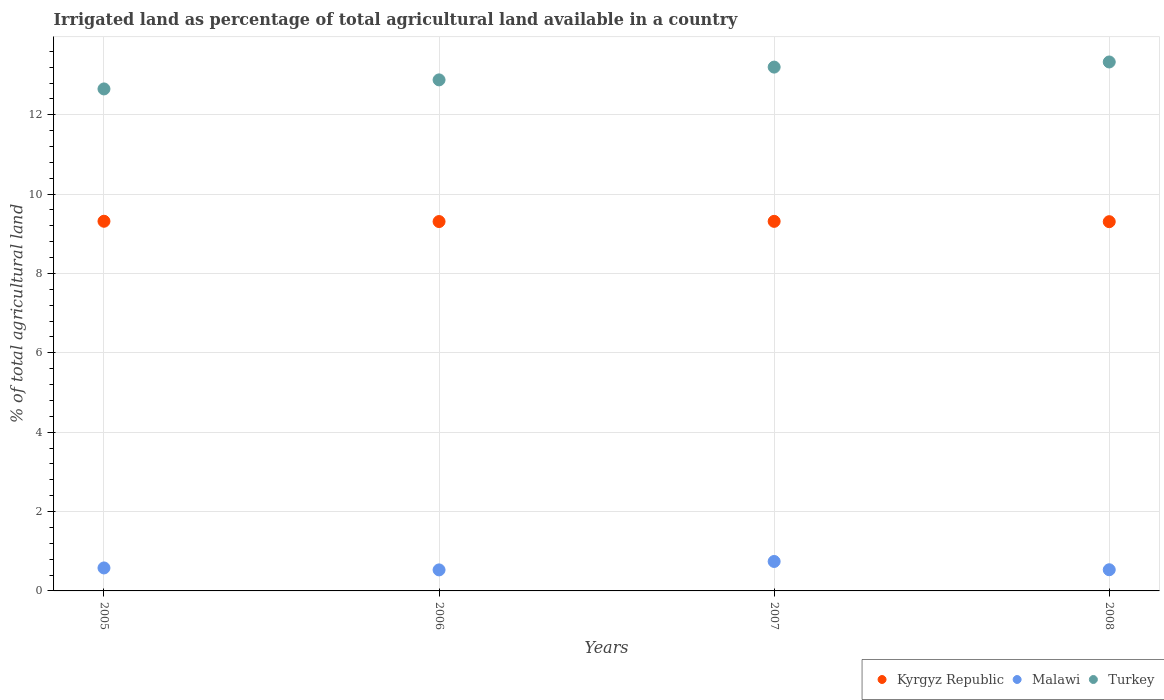How many different coloured dotlines are there?
Make the answer very short. 3. Is the number of dotlines equal to the number of legend labels?
Your answer should be compact. Yes. What is the percentage of irrigated land in Kyrgyz Republic in 2007?
Your response must be concise. 9.31. Across all years, what is the maximum percentage of irrigated land in Turkey?
Give a very brief answer. 13.33. Across all years, what is the minimum percentage of irrigated land in Kyrgyz Republic?
Keep it short and to the point. 9.31. In which year was the percentage of irrigated land in Kyrgyz Republic maximum?
Your answer should be very brief. 2005. In which year was the percentage of irrigated land in Kyrgyz Republic minimum?
Offer a very short reply. 2008. What is the total percentage of irrigated land in Turkey in the graph?
Ensure brevity in your answer.  52.06. What is the difference between the percentage of irrigated land in Turkey in 2005 and that in 2006?
Your answer should be compact. -0.23. What is the difference between the percentage of irrigated land in Malawi in 2006 and the percentage of irrigated land in Kyrgyz Republic in 2008?
Offer a very short reply. -8.78. What is the average percentage of irrigated land in Malawi per year?
Provide a short and direct response. 0.6. In the year 2007, what is the difference between the percentage of irrigated land in Kyrgyz Republic and percentage of irrigated land in Malawi?
Keep it short and to the point. 8.57. What is the ratio of the percentage of irrigated land in Malawi in 2007 to that in 2008?
Give a very brief answer. 1.39. Is the percentage of irrigated land in Malawi in 2005 less than that in 2006?
Your answer should be compact. No. What is the difference between the highest and the second highest percentage of irrigated land in Malawi?
Ensure brevity in your answer.  0.16. What is the difference between the highest and the lowest percentage of irrigated land in Kyrgyz Republic?
Offer a terse response. 0.01. In how many years, is the percentage of irrigated land in Kyrgyz Republic greater than the average percentage of irrigated land in Kyrgyz Republic taken over all years?
Ensure brevity in your answer.  2. Is the sum of the percentage of irrigated land in Malawi in 2005 and 2008 greater than the maximum percentage of irrigated land in Turkey across all years?
Offer a terse response. No. Is the percentage of irrigated land in Kyrgyz Republic strictly less than the percentage of irrigated land in Turkey over the years?
Your answer should be very brief. Yes. How many years are there in the graph?
Offer a very short reply. 4. Are the values on the major ticks of Y-axis written in scientific E-notation?
Provide a succinct answer. No. How many legend labels are there?
Provide a short and direct response. 3. How are the legend labels stacked?
Your response must be concise. Horizontal. What is the title of the graph?
Provide a succinct answer. Irrigated land as percentage of total agricultural land available in a country. Does "Middle East & North Africa (all income levels)" appear as one of the legend labels in the graph?
Provide a succinct answer. No. What is the label or title of the Y-axis?
Your answer should be very brief. % of total agricultural land. What is the % of total agricultural land in Kyrgyz Republic in 2005?
Provide a short and direct response. 9.32. What is the % of total agricultural land in Malawi in 2005?
Your response must be concise. 0.58. What is the % of total agricultural land of Turkey in 2005?
Offer a very short reply. 12.65. What is the % of total agricultural land of Kyrgyz Republic in 2006?
Make the answer very short. 9.31. What is the % of total agricultural land in Malawi in 2006?
Offer a terse response. 0.53. What is the % of total agricultural land of Turkey in 2006?
Offer a terse response. 12.88. What is the % of total agricultural land of Kyrgyz Republic in 2007?
Keep it short and to the point. 9.31. What is the % of total agricultural land of Malawi in 2007?
Offer a very short reply. 0.74. What is the % of total agricultural land in Turkey in 2007?
Offer a very short reply. 13.2. What is the % of total agricultural land in Kyrgyz Republic in 2008?
Provide a succinct answer. 9.31. What is the % of total agricultural land in Malawi in 2008?
Your answer should be very brief. 0.53. What is the % of total agricultural land of Turkey in 2008?
Offer a very short reply. 13.33. Across all years, what is the maximum % of total agricultural land in Kyrgyz Republic?
Offer a terse response. 9.32. Across all years, what is the maximum % of total agricultural land in Malawi?
Keep it short and to the point. 0.74. Across all years, what is the maximum % of total agricultural land in Turkey?
Offer a terse response. 13.33. Across all years, what is the minimum % of total agricultural land in Kyrgyz Republic?
Ensure brevity in your answer.  9.31. Across all years, what is the minimum % of total agricultural land in Malawi?
Make the answer very short. 0.53. Across all years, what is the minimum % of total agricultural land of Turkey?
Ensure brevity in your answer.  12.65. What is the total % of total agricultural land in Kyrgyz Republic in the graph?
Give a very brief answer. 37.24. What is the total % of total agricultural land of Malawi in the graph?
Keep it short and to the point. 2.38. What is the total % of total agricultural land in Turkey in the graph?
Your response must be concise. 52.06. What is the difference between the % of total agricultural land of Kyrgyz Republic in 2005 and that in 2006?
Make the answer very short. 0.01. What is the difference between the % of total agricultural land of Malawi in 2005 and that in 2006?
Offer a very short reply. 0.05. What is the difference between the % of total agricultural land in Turkey in 2005 and that in 2006?
Give a very brief answer. -0.23. What is the difference between the % of total agricultural land in Kyrgyz Republic in 2005 and that in 2007?
Make the answer very short. 0. What is the difference between the % of total agricultural land in Malawi in 2005 and that in 2007?
Your answer should be compact. -0.16. What is the difference between the % of total agricultural land of Turkey in 2005 and that in 2007?
Your response must be concise. -0.55. What is the difference between the % of total agricultural land in Kyrgyz Republic in 2005 and that in 2008?
Keep it short and to the point. 0.01. What is the difference between the % of total agricultural land of Malawi in 2005 and that in 2008?
Ensure brevity in your answer.  0.05. What is the difference between the % of total agricultural land in Turkey in 2005 and that in 2008?
Your answer should be very brief. -0.68. What is the difference between the % of total agricultural land of Kyrgyz Republic in 2006 and that in 2007?
Keep it short and to the point. -0.01. What is the difference between the % of total agricultural land in Malawi in 2006 and that in 2007?
Your answer should be very brief. -0.21. What is the difference between the % of total agricultural land in Turkey in 2006 and that in 2007?
Your answer should be very brief. -0.32. What is the difference between the % of total agricultural land in Kyrgyz Republic in 2006 and that in 2008?
Provide a short and direct response. 0. What is the difference between the % of total agricultural land in Malawi in 2006 and that in 2008?
Make the answer very short. -0. What is the difference between the % of total agricultural land in Turkey in 2006 and that in 2008?
Keep it short and to the point. -0.45. What is the difference between the % of total agricultural land in Kyrgyz Republic in 2007 and that in 2008?
Give a very brief answer. 0.01. What is the difference between the % of total agricultural land of Malawi in 2007 and that in 2008?
Give a very brief answer. 0.21. What is the difference between the % of total agricultural land of Turkey in 2007 and that in 2008?
Ensure brevity in your answer.  -0.13. What is the difference between the % of total agricultural land of Kyrgyz Republic in 2005 and the % of total agricultural land of Malawi in 2006?
Offer a very short reply. 8.79. What is the difference between the % of total agricultural land in Kyrgyz Republic in 2005 and the % of total agricultural land in Turkey in 2006?
Ensure brevity in your answer.  -3.56. What is the difference between the % of total agricultural land of Malawi in 2005 and the % of total agricultural land of Turkey in 2006?
Give a very brief answer. -12.3. What is the difference between the % of total agricultural land of Kyrgyz Republic in 2005 and the % of total agricultural land of Malawi in 2007?
Your response must be concise. 8.57. What is the difference between the % of total agricultural land of Kyrgyz Republic in 2005 and the % of total agricultural land of Turkey in 2007?
Keep it short and to the point. -3.88. What is the difference between the % of total agricultural land in Malawi in 2005 and the % of total agricultural land in Turkey in 2007?
Your answer should be very brief. -12.62. What is the difference between the % of total agricultural land of Kyrgyz Republic in 2005 and the % of total agricultural land of Malawi in 2008?
Provide a short and direct response. 8.78. What is the difference between the % of total agricultural land in Kyrgyz Republic in 2005 and the % of total agricultural land in Turkey in 2008?
Keep it short and to the point. -4.01. What is the difference between the % of total agricultural land of Malawi in 2005 and the % of total agricultural land of Turkey in 2008?
Ensure brevity in your answer.  -12.75. What is the difference between the % of total agricultural land of Kyrgyz Republic in 2006 and the % of total agricultural land of Malawi in 2007?
Make the answer very short. 8.57. What is the difference between the % of total agricultural land of Kyrgyz Republic in 2006 and the % of total agricultural land of Turkey in 2007?
Ensure brevity in your answer.  -3.89. What is the difference between the % of total agricultural land in Malawi in 2006 and the % of total agricultural land in Turkey in 2007?
Offer a terse response. -12.67. What is the difference between the % of total agricultural land of Kyrgyz Republic in 2006 and the % of total agricultural land of Malawi in 2008?
Give a very brief answer. 8.77. What is the difference between the % of total agricultural land of Kyrgyz Republic in 2006 and the % of total agricultural land of Turkey in 2008?
Provide a succinct answer. -4.02. What is the difference between the % of total agricultural land in Malawi in 2006 and the % of total agricultural land in Turkey in 2008?
Ensure brevity in your answer.  -12.8. What is the difference between the % of total agricultural land in Kyrgyz Republic in 2007 and the % of total agricultural land in Malawi in 2008?
Offer a very short reply. 8.78. What is the difference between the % of total agricultural land in Kyrgyz Republic in 2007 and the % of total agricultural land in Turkey in 2008?
Keep it short and to the point. -4.02. What is the difference between the % of total agricultural land in Malawi in 2007 and the % of total agricultural land in Turkey in 2008?
Provide a succinct answer. -12.59. What is the average % of total agricultural land in Kyrgyz Republic per year?
Provide a succinct answer. 9.31. What is the average % of total agricultural land in Malawi per year?
Offer a terse response. 0.6. What is the average % of total agricultural land of Turkey per year?
Provide a short and direct response. 13.02. In the year 2005, what is the difference between the % of total agricultural land of Kyrgyz Republic and % of total agricultural land of Malawi?
Ensure brevity in your answer.  8.74. In the year 2005, what is the difference between the % of total agricultural land in Kyrgyz Republic and % of total agricultural land in Turkey?
Make the answer very short. -3.33. In the year 2005, what is the difference between the % of total agricultural land of Malawi and % of total agricultural land of Turkey?
Keep it short and to the point. -12.07. In the year 2006, what is the difference between the % of total agricultural land in Kyrgyz Republic and % of total agricultural land in Malawi?
Keep it short and to the point. 8.78. In the year 2006, what is the difference between the % of total agricultural land in Kyrgyz Republic and % of total agricultural land in Turkey?
Keep it short and to the point. -3.57. In the year 2006, what is the difference between the % of total agricultural land of Malawi and % of total agricultural land of Turkey?
Provide a short and direct response. -12.35. In the year 2007, what is the difference between the % of total agricultural land in Kyrgyz Republic and % of total agricultural land in Malawi?
Your answer should be very brief. 8.57. In the year 2007, what is the difference between the % of total agricultural land in Kyrgyz Republic and % of total agricultural land in Turkey?
Ensure brevity in your answer.  -3.89. In the year 2007, what is the difference between the % of total agricultural land of Malawi and % of total agricultural land of Turkey?
Offer a terse response. -12.46. In the year 2008, what is the difference between the % of total agricultural land of Kyrgyz Republic and % of total agricultural land of Malawi?
Your response must be concise. 8.77. In the year 2008, what is the difference between the % of total agricultural land in Kyrgyz Republic and % of total agricultural land in Turkey?
Your answer should be compact. -4.02. In the year 2008, what is the difference between the % of total agricultural land in Malawi and % of total agricultural land in Turkey?
Offer a very short reply. -12.8. What is the ratio of the % of total agricultural land in Malawi in 2005 to that in 2006?
Your response must be concise. 1.09. What is the ratio of the % of total agricultural land of Turkey in 2005 to that in 2006?
Make the answer very short. 0.98. What is the ratio of the % of total agricultural land of Malawi in 2005 to that in 2007?
Your response must be concise. 0.78. What is the ratio of the % of total agricultural land of Malawi in 2005 to that in 2008?
Your answer should be very brief. 1.09. What is the ratio of the % of total agricultural land in Turkey in 2005 to that in 2008?
Make the answer very short. 0.95. What is the ratio of the % of total agricultural land in Malawi in 2006 to that in 2007?
Keep it short and to the point. 0.71. What is the ratio of the % of total agricultural land of Turkey in 2006 to that in 2007?
Your response must be concise. 0.98. What is the ratio of the % of total agricultural land of Malawi in 2006 to that in 2008?
Offer a very short reply. 0.99. What is the ratio of the % of total agricultural land of Turkey in 2006 to that in 2008?
Provide a short and direct response. 0.97. What is the ratio of the % of total agricultural land in Kyrgyz Republic in 2007 to that in 2008?
Give a very brief answer. 1. What is the ratio of the % of total agricultural land in Malawi in 2007 to that in 2008?
Your response must be concise. 1.39. What is the ratio of the % of total agricultural land in Turkey in 2007 to that in 2008?
Provide a short and direct response. 0.99. What is the difference between the highest and the second highest % of total agricultural land of Kyrgyz Republic?
Your answer should be compact. 0. What is the difference between the highest and the second highest % of total agricultural land in Malawi?
Ensure brevity in your answer.  0.16. What is the difference between the highest and the second highest % of total agricultural land in Turkey?
Provide a short and direct response. 0.13. What is the difference between the highest and the lowest % of total agricultural land in Kyrgyz Republic?
Offer a terse response. 0.01. What is the difference between the highest and the lowest % of total agricultural land of Malawi?
Provide a short and direct response. 0.21. What is the difference between the highest and the lowest % of total agricultural land of Turkey?
Offer a very short reply. 0.68. 